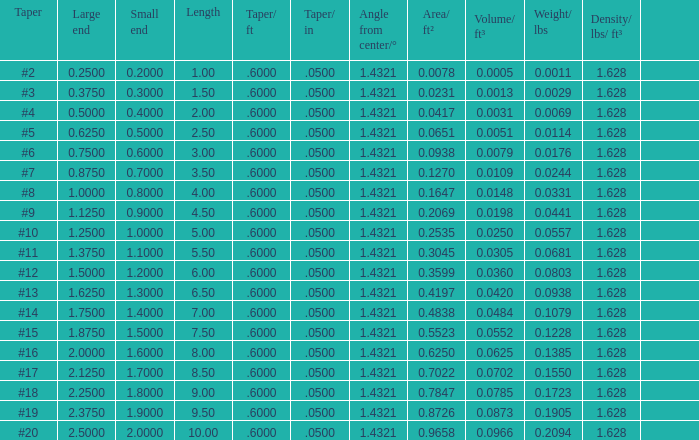Can you give me this table as a dict? {'header': ['Taper', 'Large end', 'Small end', 'Length', 'Taper/ ft', 'Taper/ in', 'Angle from center/°', 'Area/ ft²', 'Volume/ ft³', 'Weight/ lbs', 'Density/ lbs/ ft³', ''], 'rows': [['#2', '0.2500', '0.2000', '1.00', '.6000', '.0500', '1.4321', '0.0078', '0.0005', '0.0011', '1.628', ''], ['#3', '0.3750', '0.3000', '1.50', '.6000', '.0500', '1.4321', '0.0231', '0.0013', '0.0029', '1.628', ''], ['#4', '0.5000', '0.4000', '2.00', '.6000', '.0500', '1.4321', '0.0417', '0.0031', '0.0069', '1.628', ''], ['#5', '0.6250', '0.5000', '2.50', '.6000', '.0500', '1.4321', '0.0651', '0.0051', '0.0114', '1.628', ''], ['#6', '0.7500', '0.6000', '3.00', '.6000', '.0500', '1.4321', '0.0938', '0.0079', '0.0176', '1.628', ''], ['#7', '0.8750', '0.7000', '3.50', '.6000', '.0500', '1.4321', '0.1270', '0.0109', '0.0244', '1.628', ''], ['#8', '1.0000', '0.8000', '4.00', '.6000', '.0500', '1.4321', '0.1647', '0.0148', '0.0331', '1.628', ''], ['#9', '1.1250', '0.9000', '4.50', '.6000', '.0500', '1.4321', '0.2069', '0.0198', '0.0441', '1.628', ''], ['#10', '1.2500', '1.0000', '5.00', '.6000', '.0500', '1.4321', '0.2535', '0.0250', '0.0557', '1.628', ''], ['#11', '1.3750', '1.1000', '5.50', '.6000', '.0500', '1.4321', '0.3045', '0.0305', '0.0681', '1.628', ''], ['#12', '1.5000', '1.2000', '6.00', '.6000', '.0500', '1.4321', '0.3599', '0.0360', '0.0803', '1.628', ''], ['#13', '1.6250', '1.3000', '6.50', '.6000', '.0500', '1.4321', '0.4197', '0.0420', '0.0938', '1.628', ''], ['#14', '1.7500', '1.4000', '7.00', '.6000', '.0500', '1.4321', '0.4838', '0.0484', '0.1079', '1.628', ''], ['#15', '1.8750', '1.5000', '7.50', '.6000', '.0500', '1.4321', '0.5523', '0.0552', '0.1228', '1.628', ''], ['#16', '2.0000', '1.6000', '8.00', '.6000', '.0500', '1.4321', '0.6250', '0.0625', '0.1385', '1.628', ''], ['#17', '2.1250', '1.7000', '8.50', '.6000', '.0500', '1.4321', '0.7022', '0.0702', '0.1550', '1.628', ''], ['#18', '2.2500', '1.8000', '9.00', '.6000', '.0500', '1.4321', '0.7847', '0.0785', '0.1723', '1.628', ''], ['#19', '2.3750', '1.9000', '9.50', '.6000', '.0500', '1.4321', '0.8726', '0.0873', '0.1905', '1.628', ''], ['#20', '2.5000', '2.0000', '10.00', '.6000', '.0500', '1.4321', '0.9658', '0.0966', '0.2094', '1.628', '']]} Which Angle from center/° has a Taper/ft smaller than 0.6000000000000001? 19.0. 